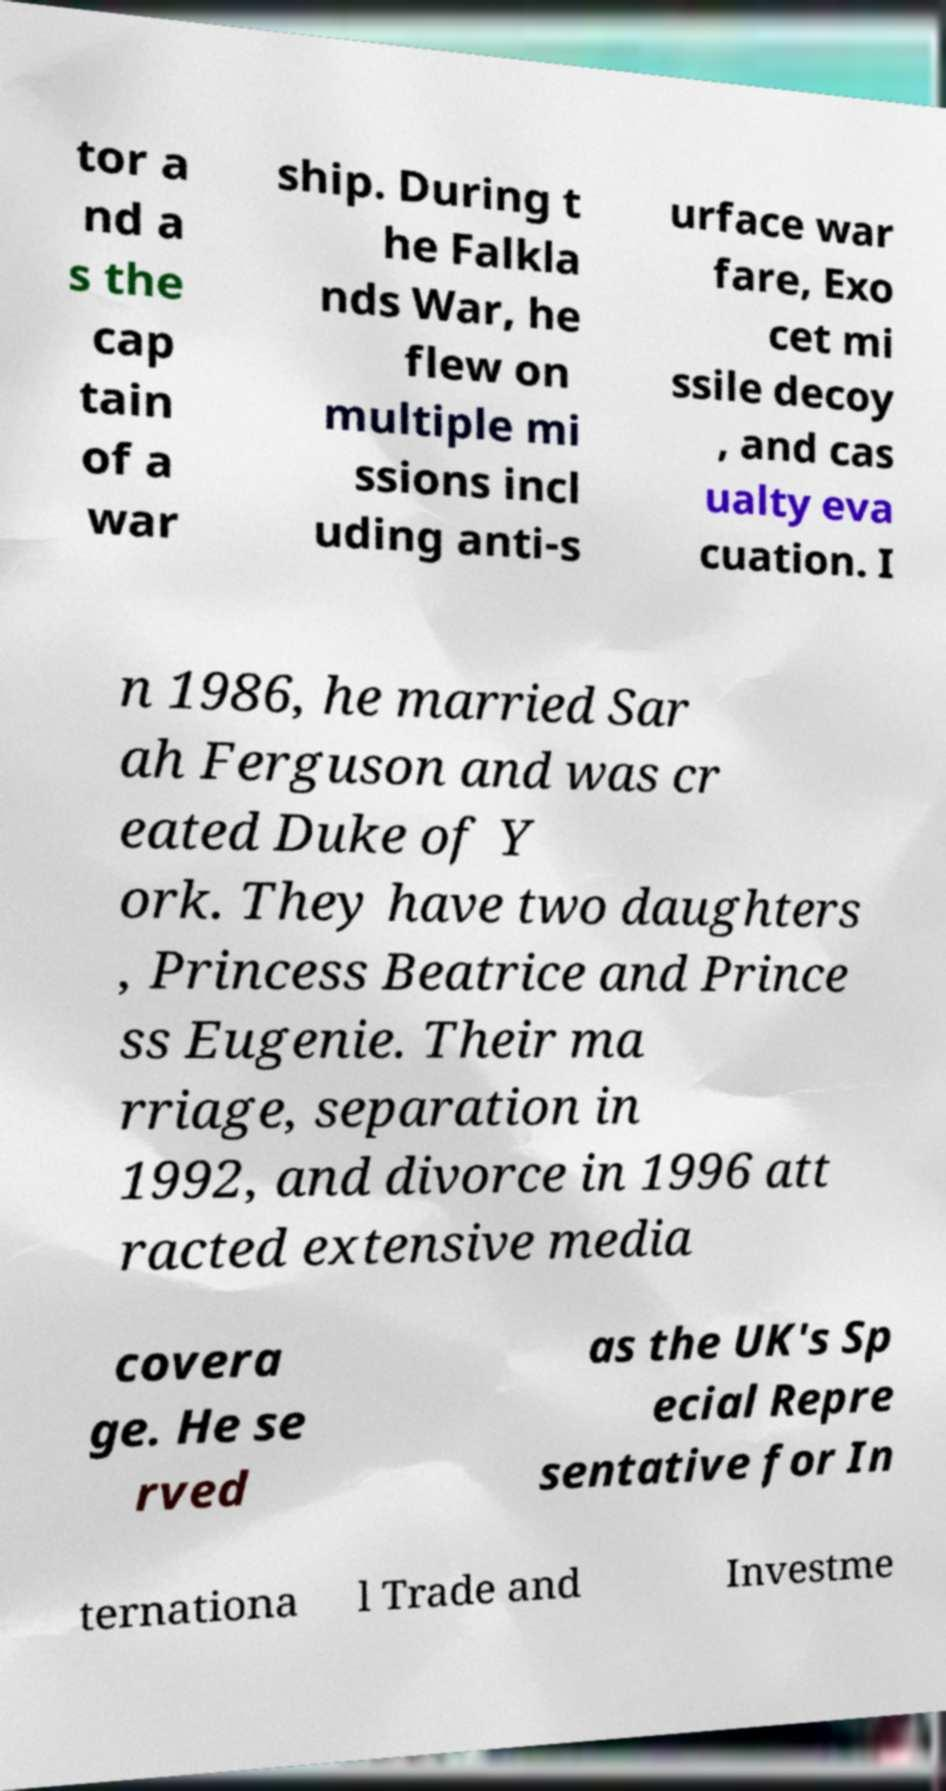Could you extract and type out the text from this image? tor a nd a s the cap tain of a war ship. During t he Falkla nds War, he flew on multiple mi ssions incl uding anti-s urface war fare, Exo cet mi ssile decoy , and cas ualty eva cuation. I n 1986, he married Sar ah Ferguson and was cr eated Duke of Y ork. They have two daughters , Princess Beatrice and Prince ss Eugenie. Their ma rriage, separation in 1992, and divorce in 1996 att racted extensive media covera ge. He se rved as the UK's Sp ecial Repre sentative for In ternationa l Trade and Investme 